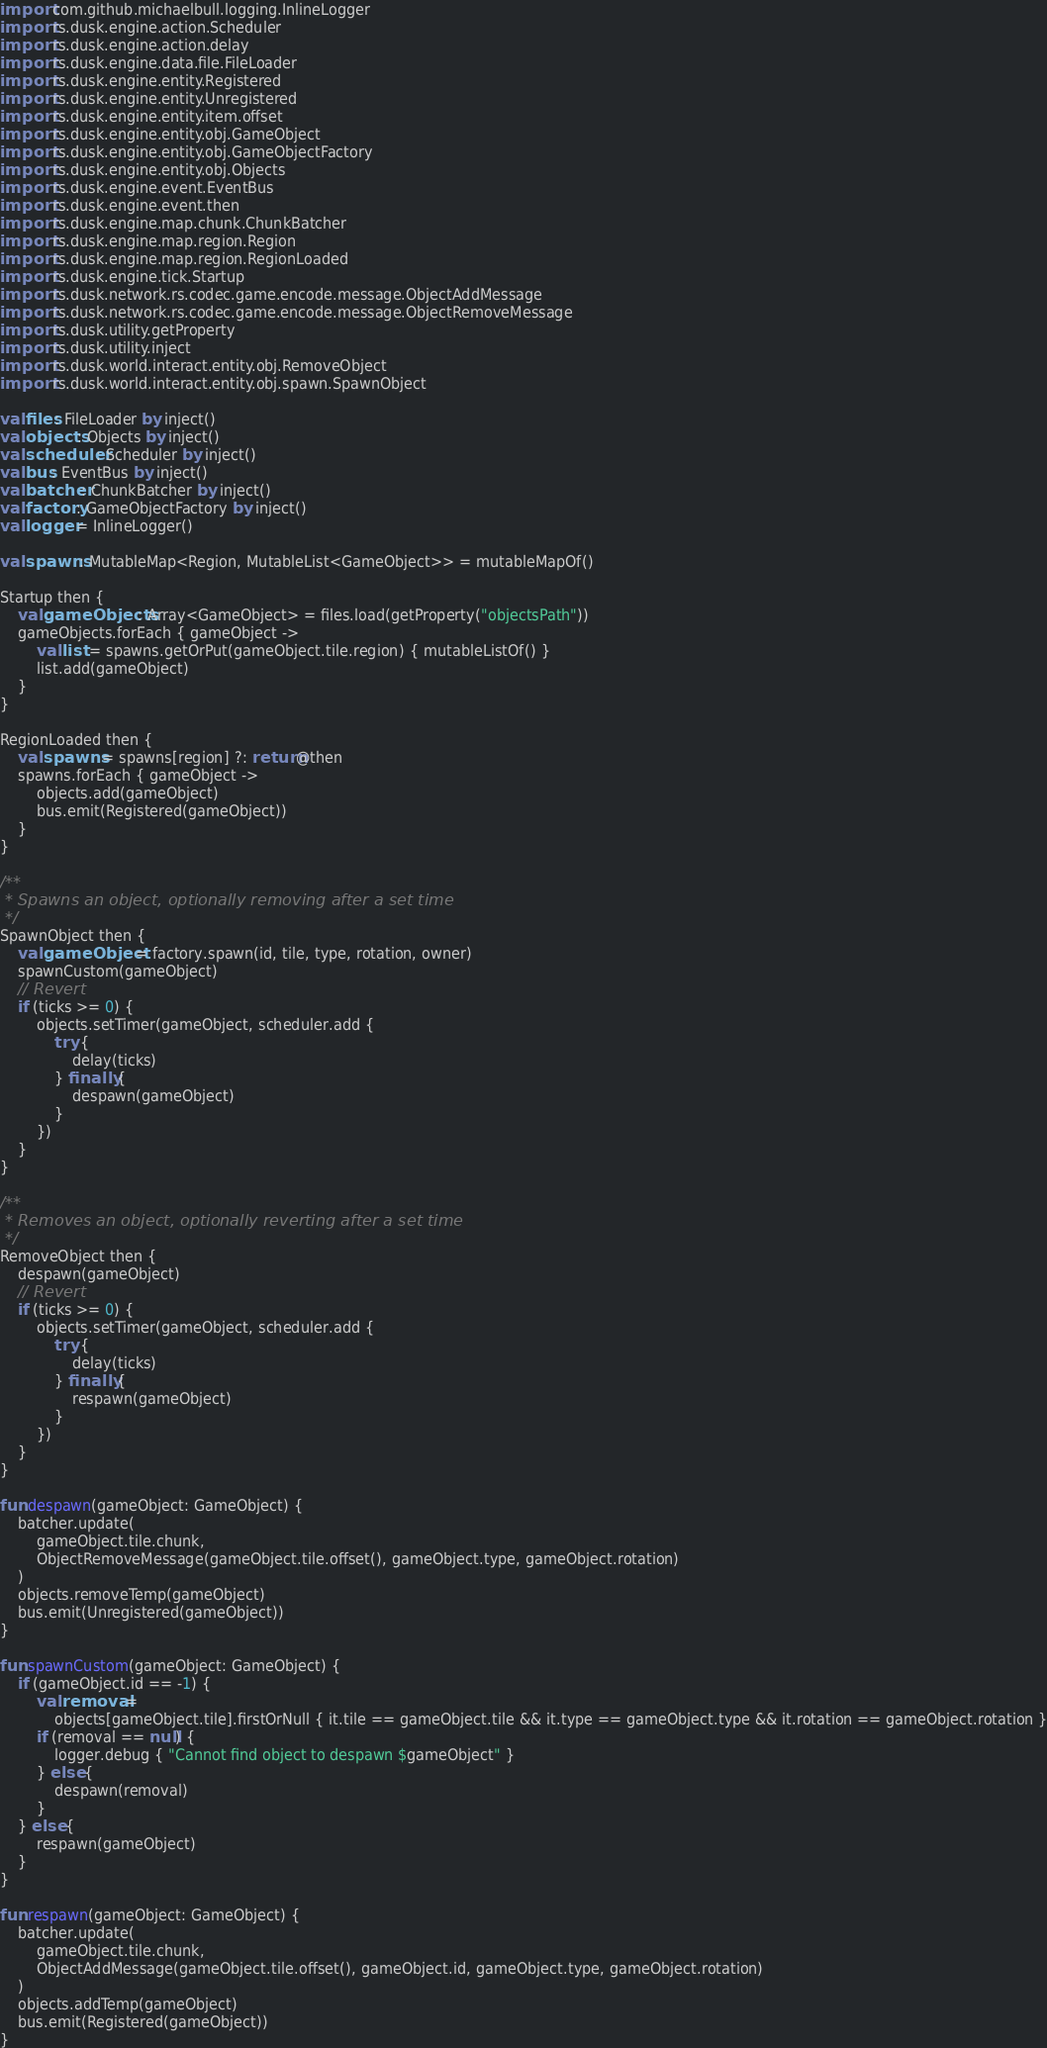<code> <loc_0><loc_0><loc_500><loc_500><_Kotlin_>import com.github.michaelbull.logging.InlineLogger
import rs.dusk.engine.action.Scheduler
import rs.dusk.engine.action.delay
import rs.dusk.engine.data.file.FileLoader
import rs.dusk.engine.entity.Registered
import rs.dusk.engine.entity.Unregistered
import rs.dusk.engine.entity.item.offset
import rs.dusk.engine.entity.obj.GameObject
import rs.dusk.engine.entity.obj.GameObjectFactory
import rs.dusk.engine.entity.obj.Objects
import rs.dusk.engine.event.EventBus
import rs.dusk.engine.event.then
import rs.dusk.engine.map.chunk.ChunkBatcher
import rs.dusk.engine.map.region.Region
import rs.dusk.engine.map.region.RegionLoaded
import rs.dusk.engine.tick.Startup
import rs.dusk.network.rs.codec.game.encode.message.ObjectAddMessage
import rs.dusk.network.rs.codec.game.encode.message.ObjectRemoveMessage
import rs.dusk.utility.getProperty
import rs.dusk.utility.inject
import rs.dusk.world.interact.entity.obj.RemoveObject
import rs.dusk.world.interact.entity.obj.spawn.SpawnObject

val files: FileLoader by inject()
val objects: Objects by inject()
val scheduler: Scheduler by inject()
val bus: EventBus by inject()
val batcher: ChunkBatcher by inject()
val factory: GameObjectFactory by inject()
val logger = InlineLogger()

val spawns: MutableMap<Region, MutableList<GameObject>> = mutableMapOf()

Startup then {
    val gameObjects: Array<GameObject> = files.load(getProperty("objectsPath"))
    gameObjects.forEach { gameObject ->
        val list = spawns.getOrPut(gameObject.tile.region) { mutableListOf() }
        list.add(gameObject)
    }
}

RegionLoaded then {
    val spawns = spawns[region] ?: return@then
    spawns.forEach { gameObject ->
        objects.add(gameObject)
        bus.emit(Registered(gameObject))
    }
}

/**
 * Spawns an object, optionally removing after a set time
 */
SpawnObject then {
    val gameObject = factory.spawn(id, tile, type, rotation, owner)
    spawnCustom(gameObject)
    // Revert
    if (ticks >= 0) {
        objects.setTimer(gameObject, scheduler.add {
            try {
                delay(ticks)
            } finally {
                despawn(gameObject)
            }
        })
    }
}

/**
 * Removes an object, optionally reverting after a set time
 */
RemoveObject then {
    despawn(gameObject)
    // Revert
    if (ticks >= 0) {
        objects.setTimer(gameObject, scheduler.add {
            try {
                delay(ticks)
            } finally {
                respawn(gameObject)
            }
        })
    }
}

fun despawn(gameObject: GameObject) {
    batcher.update(
        gameObject.tile.chunk,
        ObjectRemoveMessage(gameObject.tile.offset(), gameObject.type, gameObject.rotation)
    )
    objects.removeTemp(gameObject)
    bus.emit(Unregistered(gameObject))
}

fun spawnCustom(gameObject: GameObject) {
    if (gameObject.id == -1) {
        val removal =
            objects[gameObject.tile].firstOrNull { it.tile == gameObject.tile && it.type == gameObject.type && it.rotation == gameObject.rotation }
        if (removal == null) {
            logger.debug { "Cannot find object to despawn $gameObject" }
        } else {
            despawn(removal)
        }
    } else {
        respawn(gameObject)
    }
}

fun respawn(gameObject: GameObject) {
    batcher.update(
        gameObject.tile.chunk,
        ObjectAddMessage(gameObject.tile.offset(), gameObject.id, gameObject.type, gameObject.rotation)
    )
    objects.addTemp(gameObject)
    bus.emit(Registered(gameObject))
}</code> 